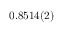Convert formula to latex. <formula><loc_0><loc_0><loc_500><loc_500>0 . 8 5 1 4 ( 2 )</formula> 